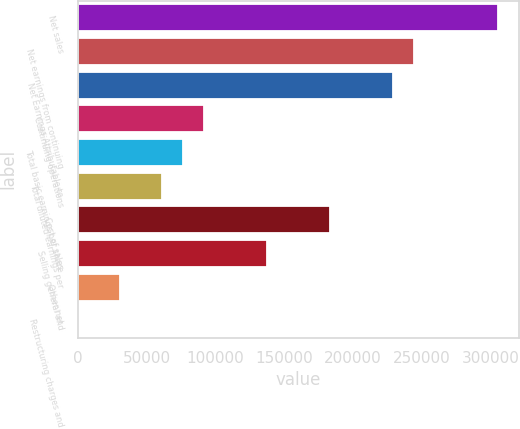Convert chart. <chart><loc_0><loc_0><loc_500><loc_500><bar_chart><fcel>Net sales<fcel>Net earnings from continuing<fcel>Net Earnings Attributable to<fcel>Continuing operations<fcel>Total basic earnings per share<fcel>Total diluted earnings per<fcel>Cost of sales<fcel>Selling general and<fcel>Other net<fcel>Restructuring charges and<nl><fcel>305412<fcel>244329<fcel>229059<fcel>91623.8<fcel>76353.2<fcel>61082.6<fcel>183247<fcel>137435<fcel>30541.5<fcel>0.4<nl></chart> 